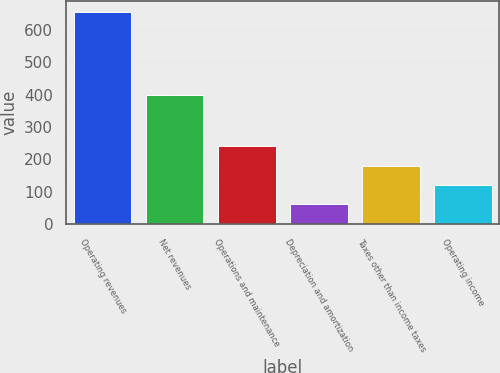<chart> <loc_0><loc_0><loc_500><loc_500><bar_chart><fcel>Operating revenues<fcel>Net revenues<fcel>Operations and maintenance<fcel>Depreciation and amortization<fcel>Taxes other than income taxes<fcel>Operating income<nl><fcel>656<fcel>400<fcel>240.2<fcel>62<fcel>180.8<fcel>121.4<nl></chart> 